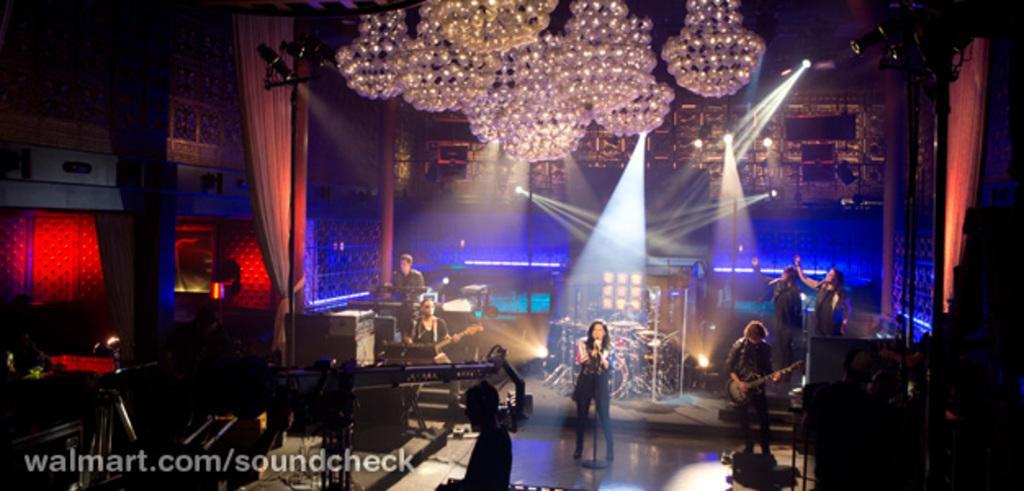Please provide a concise description of this image. In this image, we can see some persons standing and wearing clothes. There is a person in the bottom right of the image playing a guitar. There is a chandler at the top of the image. There are curtains on the left side of the image. 